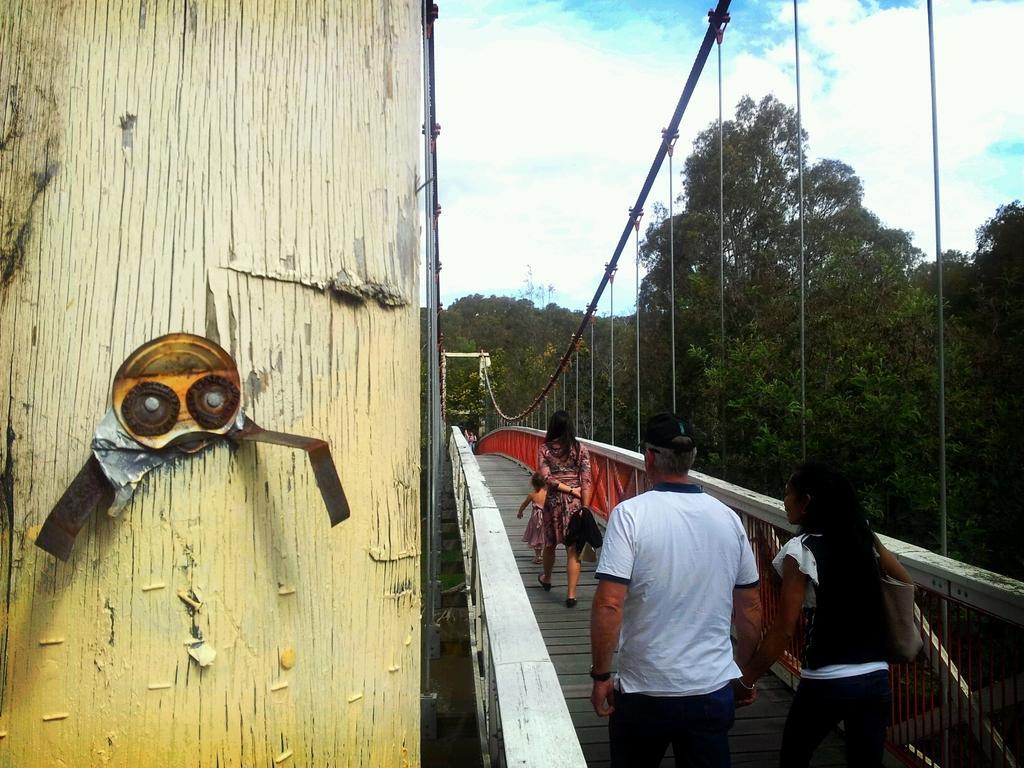Please provide a concise description of this image. On the right side of the image there is a bridge and we can see people walking. On the left there is a wall. In the background there are trees and sky. 